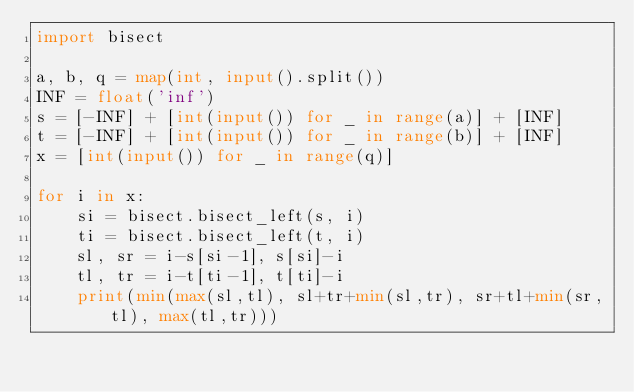Convert code to text. <code><loc_0><loc_0><loc_500><loc_500><_Python_>import bisect

a, b, q = map(int, input().split())
INF = float('inf')
s = [-INF] + [int(input()) for _ in range(a)] + [INF]
t = [-INF] + [int(input()) for _ in range(b)] + [INF]
x = [int(input()) for _ in range(q)]

for i in x:
    si = bisect.bisect_left(s, i)
    ti = bisect.bisect_left(t, i)
    sl, sr = i-s[si-1], s[si]-i
    tl, tr = i-t[ti-1], t[ti]-i
    print(min(max(sl,tl), sl+tr+min(sl,tr), sr+tl+min(sr,tl), max(tl,tr)))</code> 